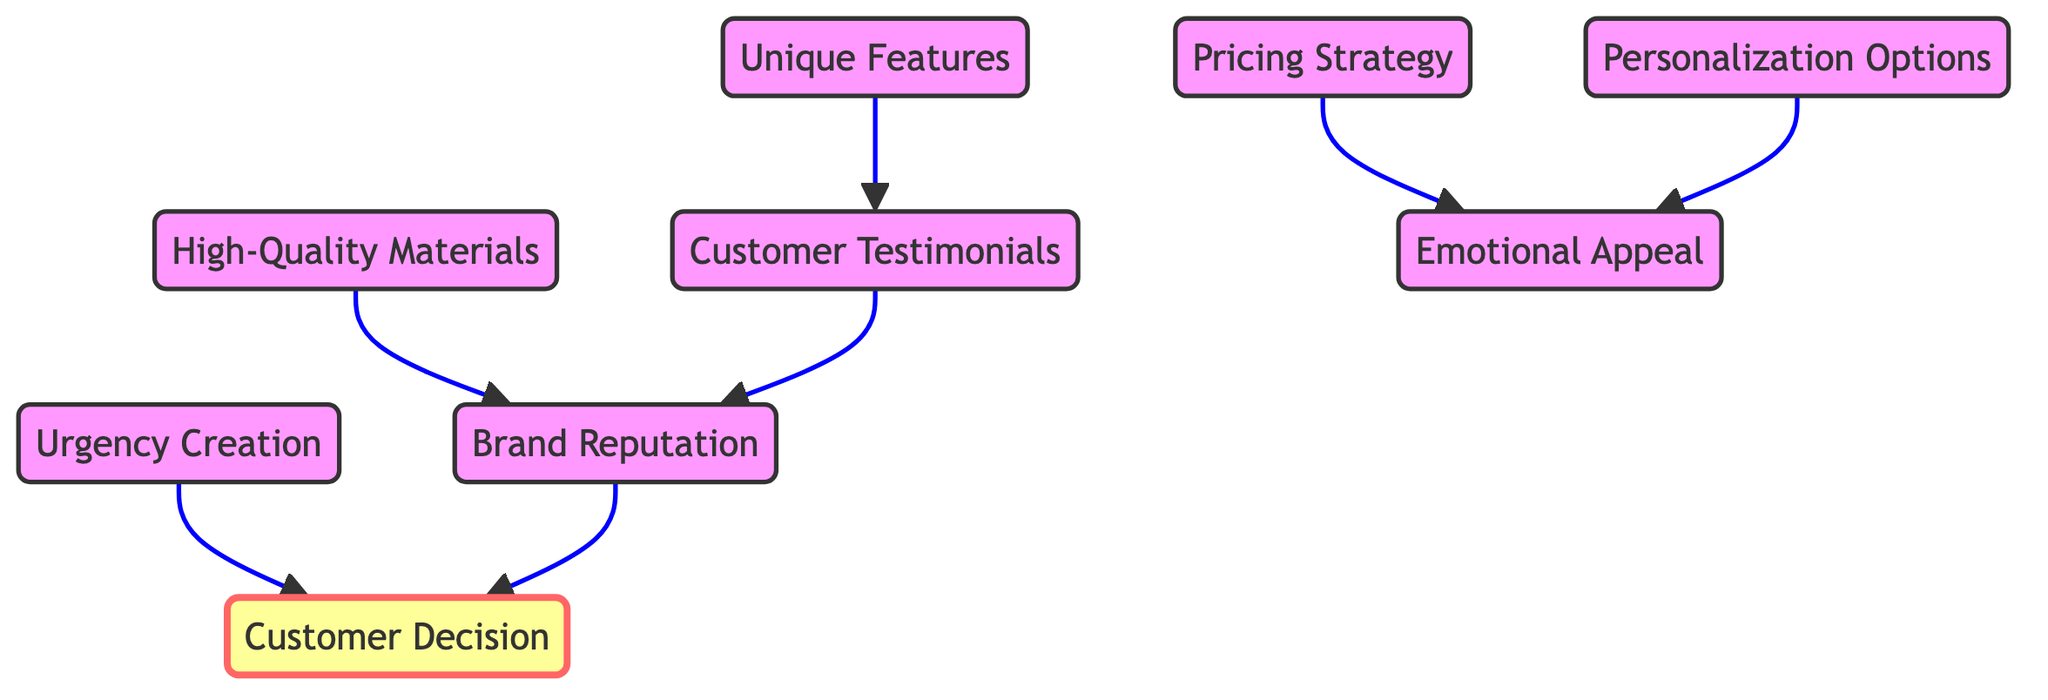What are the total number of nodes in the diagram? The diagram lists the nodes such as High-Quality Materials, Brand Reputation, Unique Features, Pricing Strategy, Customer Testimonials, Emotional Appeal, Urgency Creation, and Personalization Options. Counting these nodes gives us a total of 8.
Answer: 8 Which node directly influences Customer Testimonials? From the diagram, Unique Features has a direct edge leading to Customer Testimonials, indicating that it influences this node directly.
Answer: Unique Features What is the relationship between Brand Reputation and Customer Decision? The diagram shows a direct connection from Brand Reputation to Customer Decision, meaning that Brand Reputation plays a role in influencing Customer Decision directly.
Answer: Brand Reputation How many edges are in the diagram? By examining the connections between the nodes, I count the edges: High-Quality Materials to Brand Reputation, Unique Features to Customer Testimonials, Pricing Strategy to Emotional Appeal, Urgency Creation to Customer Decision, Personalization Options to Emotional Appeal, Customer Testimonials to Brand Reputation, and Brand Reputation to Customer Decision. There are a total of 7 edges.
Answer: 7 Does High-Quality Materials influence Customer Decision directly? Analyzing the paths in the diagram, High-Quality Materials does not have a direct edge leading to Customer Decision. Instead, it influences Brand Reputation, which in turn directly influences Customer Decision. Therefore, it does not have a direct influence.
Answer: No Which feature creates urgency in customer decision-making? Urgency Creation has a direct edge leading to Customer Decision, indicating that this feature is responsible for creating a sense of urgency that impacts decision-making.
Answer: Urgency Creation Which two nodes contribute to Emotional Appeal? The diagram indicates that both Pricing Strategy and Personalization Options have edges leading to Emotional Appeal, suggesting that these features contribute to creating an emotional response.
Answer: Pricing Strategy, Personalization Options How does Customer Testimonials impact Brand Reputation? Customer Testimonials has a direct influence (edge) to Brand Reputation, thus reinforcing or enhancing the perception of the brand based on customer feedback.
Answer: Direct influence 